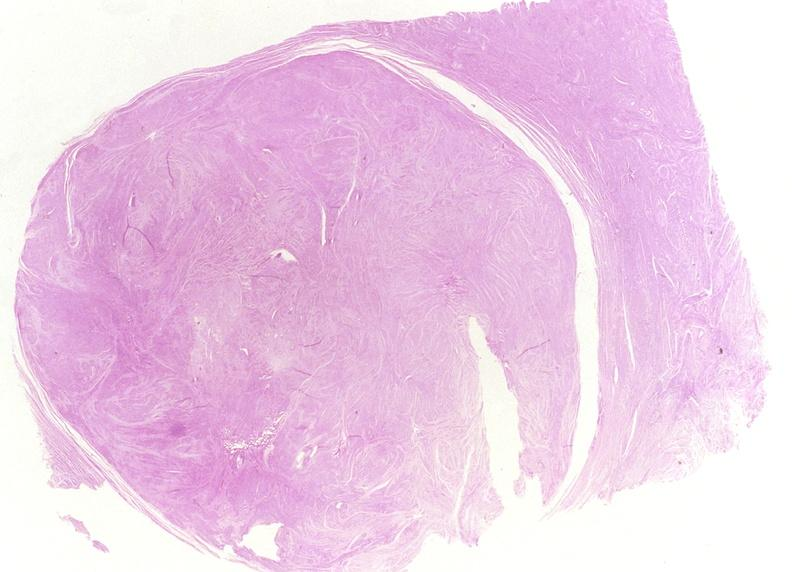s female reproductive present?
Answer the question using a single word or phrase. Yes 